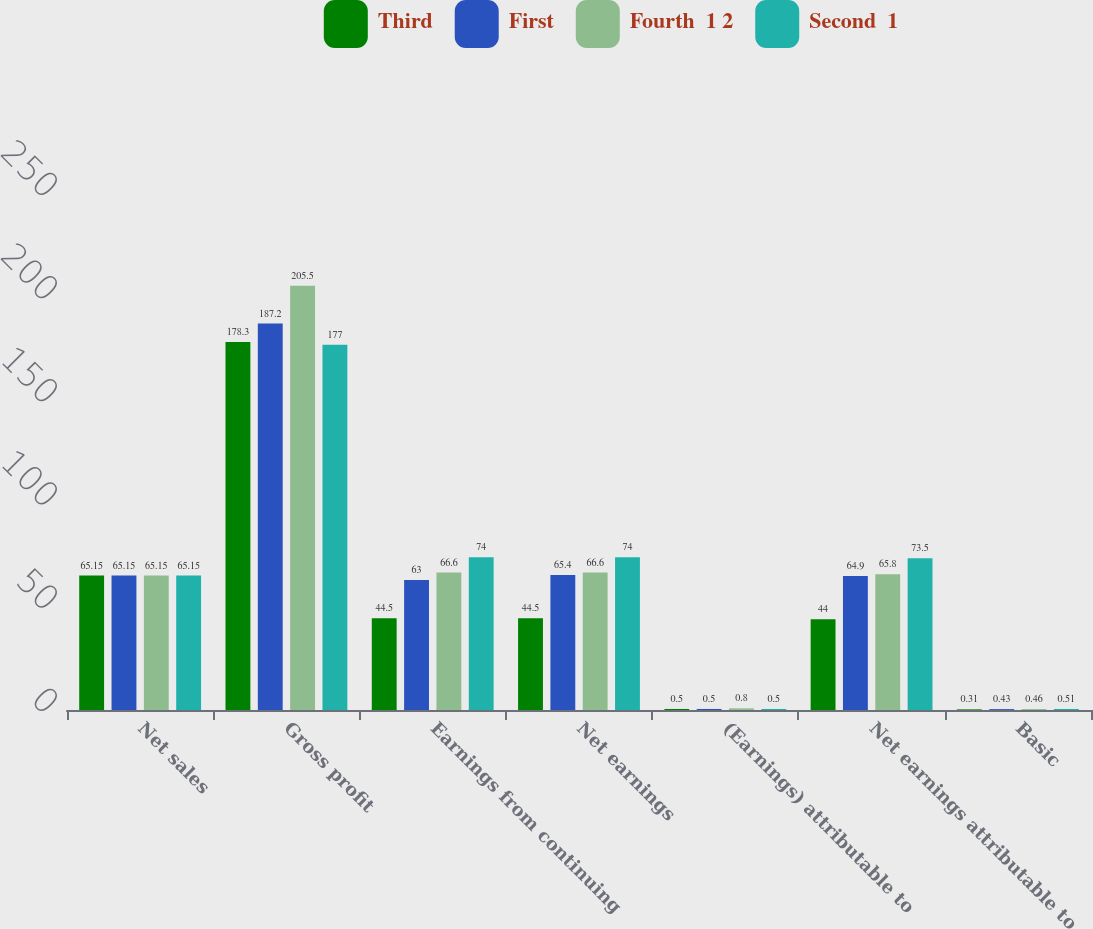Convert chart to OTSL. <chart><loc_0><loc_0><loc_500><loc_500><stacked_bar_chart><ecel><fcel>Net sales<fcel>Gross profit<fcel>Earnings from continuing<fcel>Net earnings<fcel>(Earnings) attributable to<fcel>Net earnings attributable to<fcel>Basic<nl><fcel>Third<fcel>65.15<fcel>178.3<fcel>44.5<fcel>44.5<fcel>0.5<fcel>44<fcel>0.31<nl><fcel>First<fcel>65.15<fcel>187.2<fcel>63<fcel>65.4<fcel>0.5<fcel>64.9<fcel>0.43<nl><fcel>Fourth  1 2<fcel>65.15<fcel>205.5<fcel>66.6<fcel>66.6<fcel>0.8<fcel>65.8<fcel>0.46<nl><fcel>Second  1<fcel>65.15<fcel>177<fcel>74<fcel>74<fcel>0.5<fcel>73.5<fcel>0.51<nl></chart> 